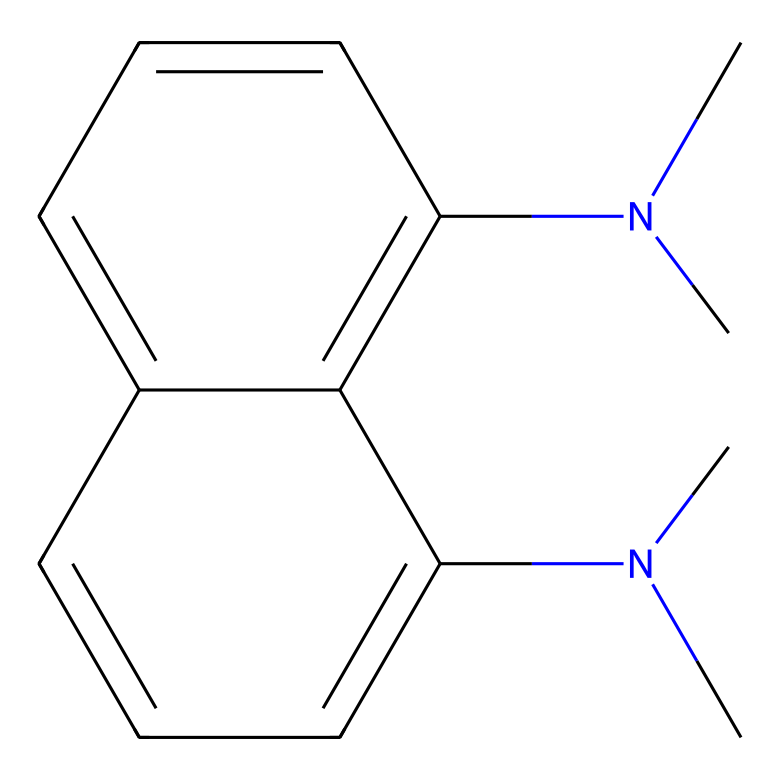What is the molecular formula of 1,8-bis(dimethylamino)naphthalene? By analyzing the SMILES representation, we can interpret the structure and count the number of each type of atom. The structure contains 12 carbon atoms, 16 hydrogen atoms, and 2 nitrogen atoms, leading to a molecular formula C12H16N2.
Answer: C12H16N2 How many nitrogen atoms are present in the structure? In the provided SMILES, "N(C)" indicates the presence of nitrogen atoms connected to dimethyl groups. Counting these gives a total of 2 nitrogen atoms.
Answer: 2 What type of chemical is 1,8-bis(dimethylamino)naphthalene classified as? The presence of two tertiary amine groups (from the dimethylamino substituents) in its structure classifies this compound as a superbase, which is a strong base.
Answer: superbase How many rings are present in the structure? The SMILES denotes a fused bicyclic structure, specifically a naphthalene system, which consists of 2 interconnected benzene rings, totaling 2 rings.
Answer: 2 What functional groups are present in 1,8-bis(dimethylamino)naphthalene? Examining the structure reveals that there are two dimethylamino groups (-N(CH3)2), characterizing it with amine functional groups.
Answer: amine What property makes this chemical relevant for fluorescent dyes in astronomical imaging? The presence of the naphthalene framework allows for effective light absorption and emission properties, which are critical in fluorescent dye applications.
Answer: fluorescence 